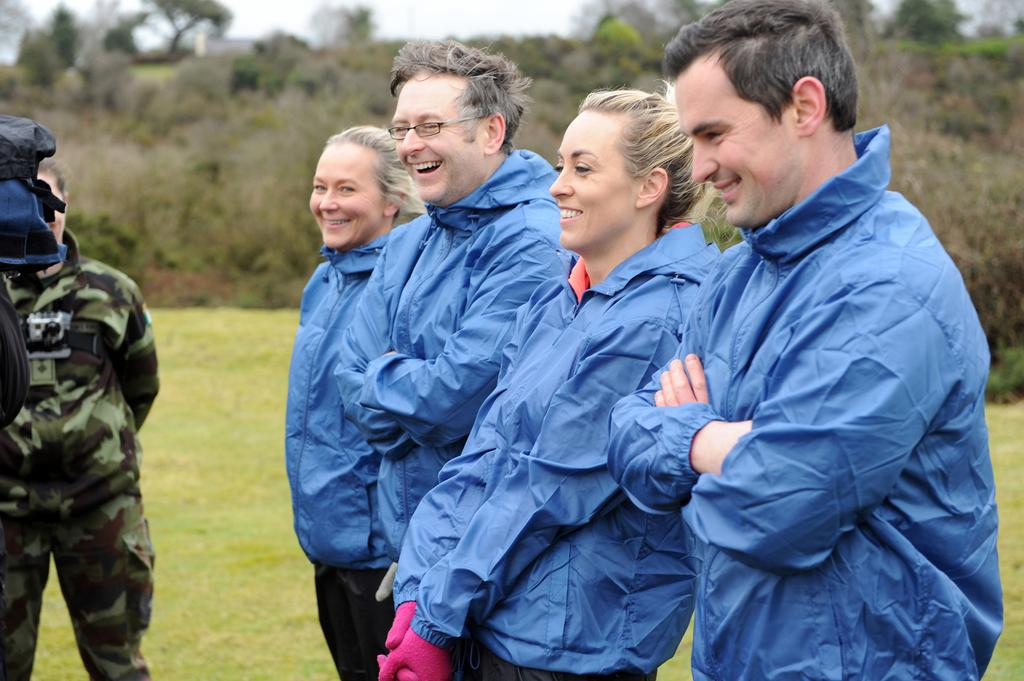How many people are in the image? There are four persons standing in the image. What are the people wearing? The persons are wearing blue jackets. What is the facial expression of the people in the image? The persons are smiling. What type of ground is visible in the image? There is grass on the ground in the image. What can be seen in the background of the image? There are trees in the background of the image. Where is the person located in the image? There is a person on the left side of the image. What direction is the car moving in the image? There is no car present in the image. What decision did the group make before taking the photo? The provided facts do not give any information about a decision made by the group before taking the photo. 